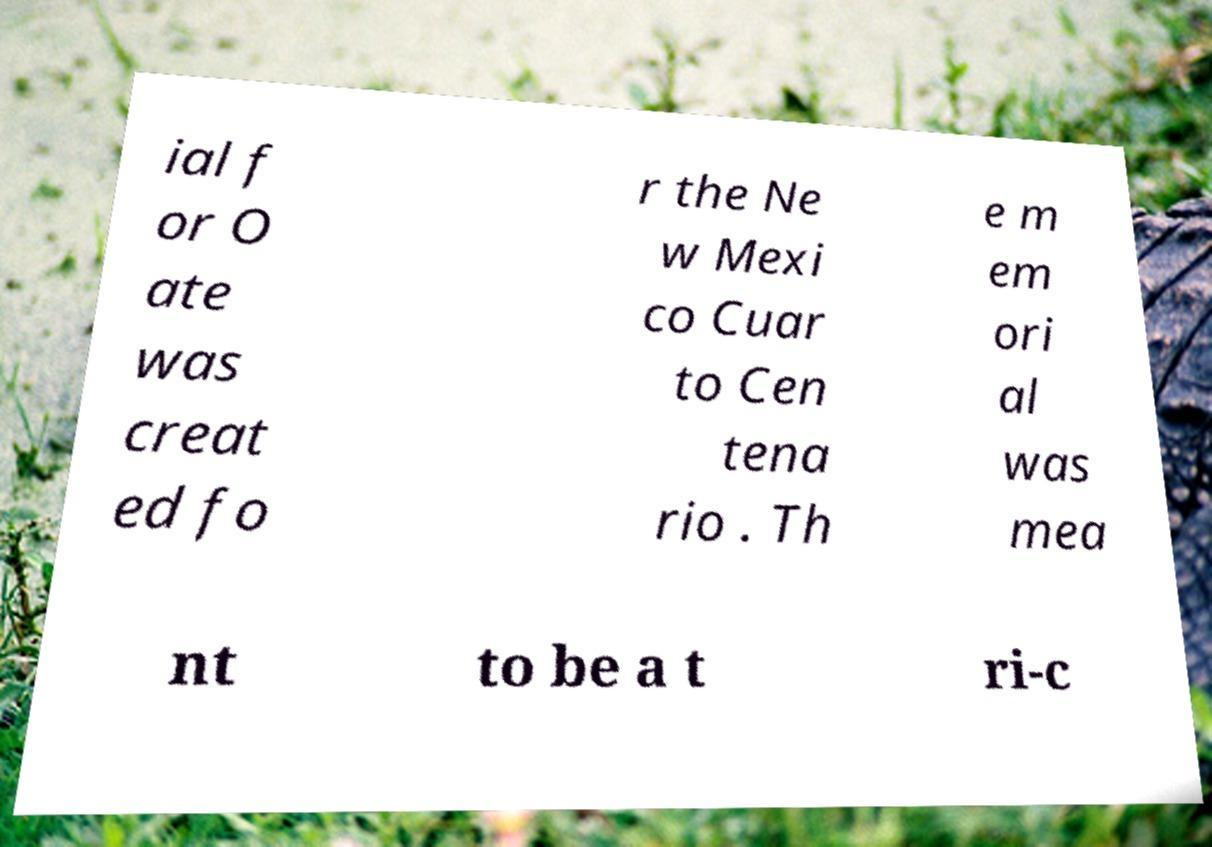There's text embedded in this image that I need extracted. Can you transcribe it verbatim? ial f or O ate was creat ed fo r the Ne w Mexi co Cuar to Cen tena rio . Th e m em ori al was mea nt to be a t ri-c 